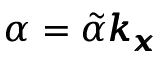Convert formula to latex. <formula><loc_0><loc_0><loc_500><loc_500>\alpha = \tilde { \alpha } \pm b { k _ { x } }</formula> 